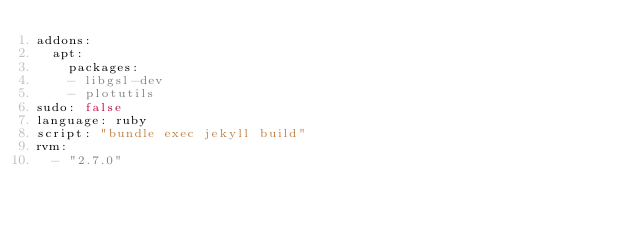<code> <loc_0><loc_0><loc_500><loc_500><_YAML_>addons:
  apt:
    packages:
    - libgsl-dev
    - plotutils
sudo: false
language: ruby
script: "bundle exec jekyll build"
rvm:
  - "2.7.0"
</code> 